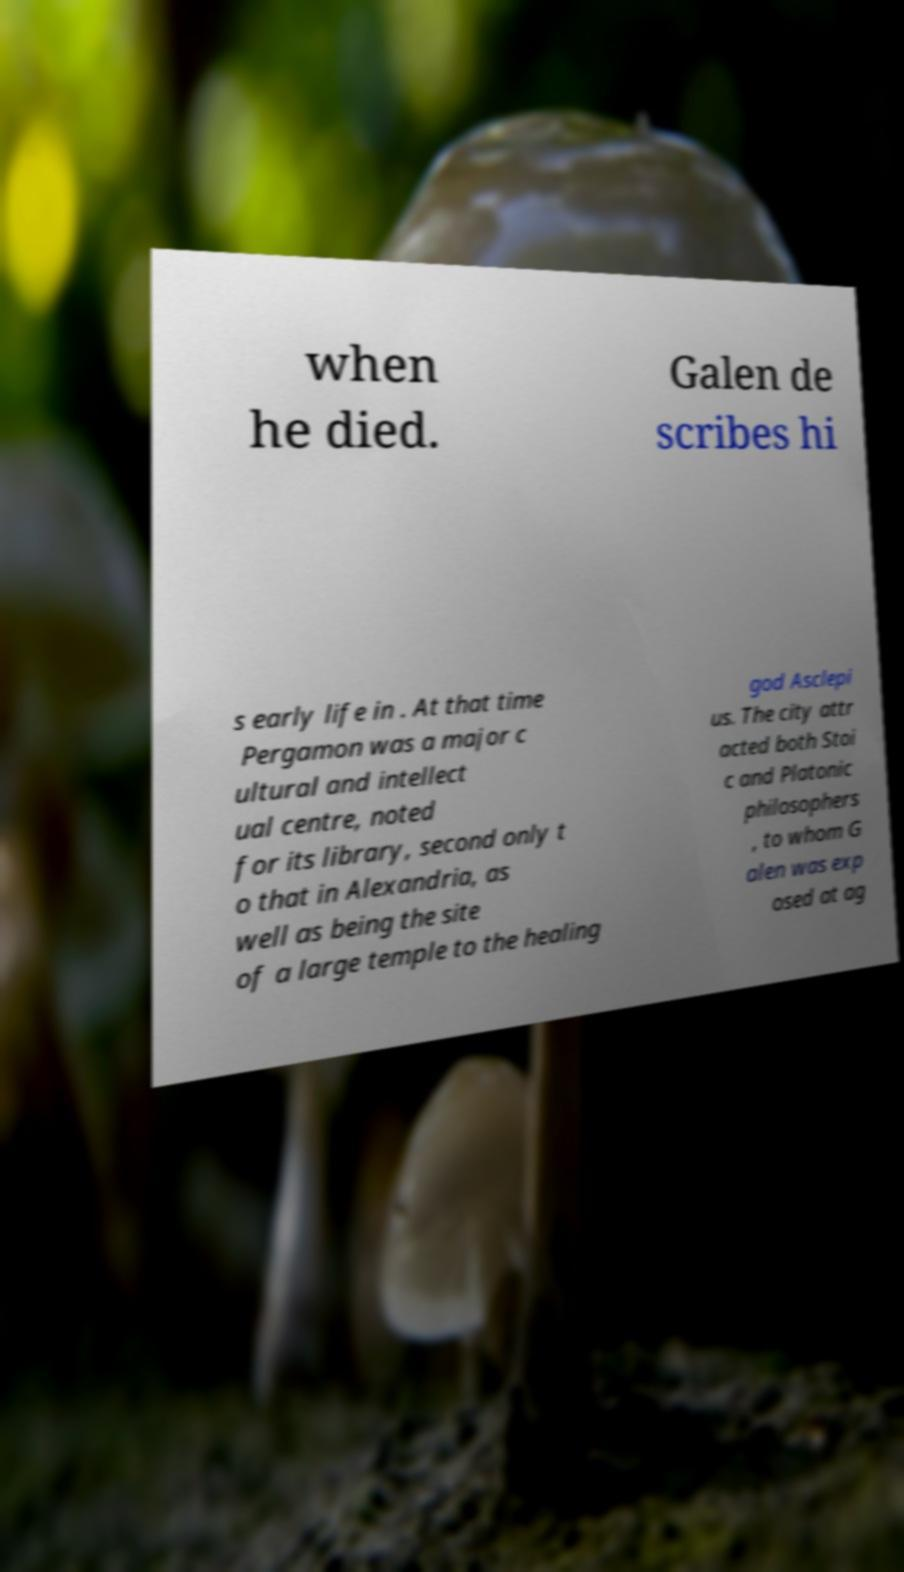Can you read and provide the text displayed in the image?This photo seems to have some interesting text. Can you extract and type it out for me? when he died. Galen de scribes hi s early life in . At that time Pergamon was a major c ultural and intellect ual centre, noted for its library, second only t o that in Alexandria, as well as being the site of a large temple to the healing god Asclepi us. The city attr acted both Stoi c and Platonic philosophers , to whom G alen was exp osed at ag 